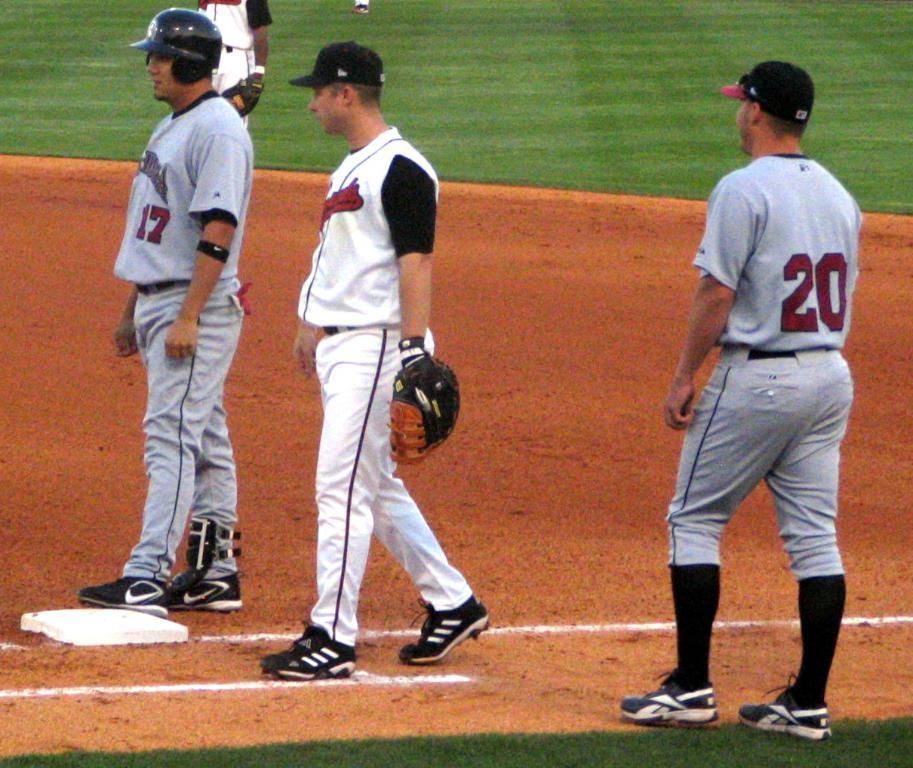<image>
Provide a brief description of the given image. number 17 and number 20 are from the team with gray jersey 